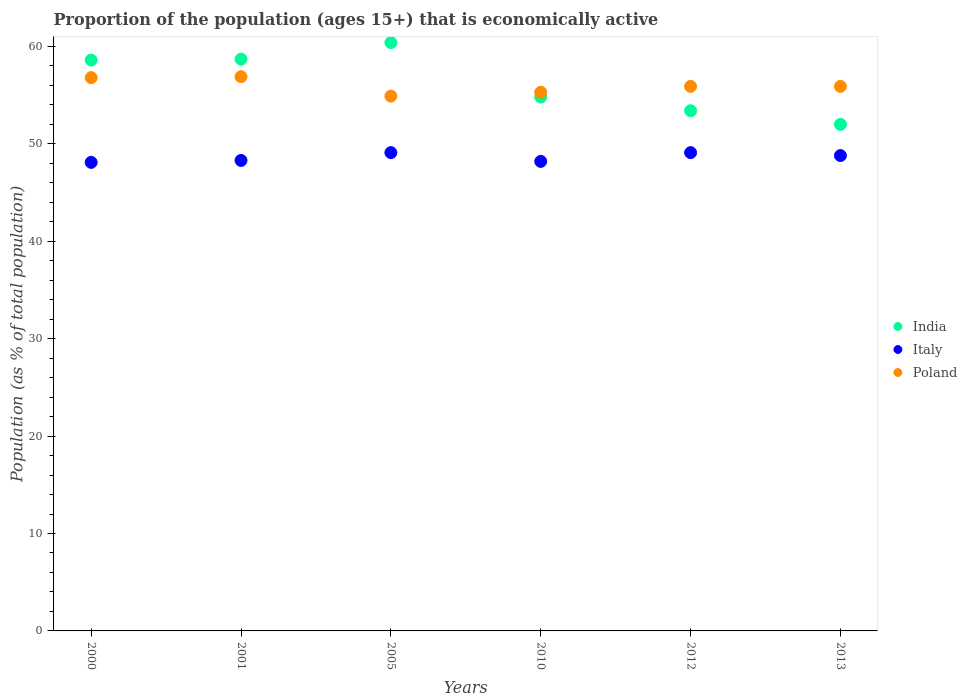What is the proportion of the population that is economically active in Poland in 2012?
Give a very brief answer. 55.9. Across all years, what is the maximum proportion of the population that is economically active in Poland?
Keep it short and to the point. 56.9. Across all years, what is the minimum proportion of the population that is economically active in India?
Keep it short and to the point. 52. In which year was the proportion of the population that is economically active in Poland maximum?
Provide a succinct answer. 2001. In which year was the proportion of the population that is economically active in Poland minimum?
Your answer should be compact. 2005. What is the total proportion of the population that is economically active in Poland in the graph?
Ensure brevity in your answer.  335.7. What is the difference between the proportion of the population that is economically active in Italy in 2005 and that in 2010?
Keep it short and to the point. 0.9. What is the difference between the proportion of the population that is economically active in India in 2001 and the proportion of the population that is economically active in Poland in 2005?
Keep it short and to the point. 3.8. What is the average proportion of the population that is economically active in Poland per year?
Ensure brevity in your answer.  55.95. In the year 2012, what is the difference between the proportion of the population that is economically active in Poland and proportion of the population that is economically active in Italy?
Offer a very short reply. 6.8. What is the ratio of the proportion of the population that is economically active in Italy in 2001 to that in 2012?
Offer a very short reply. 0.98. What is the difference between the highest and the second highest proportion of the population that is economically active in Italy?
Offer a very short reply. 0. Is the sum of the proportion of the population that is economically active in Italy in 2005 and 2012 greater than the maximum proportion of the population that is economically active in India across all years?
Your answer should be very brief. Yes. Is it the case that in every year, the sum of the proportion of the population that is economically active in India and proportion of the population that is economically active in Italy  is greater than the proportion of the population that is economically active in Poland?
Your response must be concise. Yes. How many dotlines are there?
Provide a short and direct response. 3. What is the difference between two consecutive major ticks on the Y-axis?
Your answer should be compact. 10. Does the graph contain any zero values?
Provide a succinct answer. No. Does the graph contain grids?
Keep it short and to the point. No. What is the title of the graph?
Offer a very short reply. Proportion of the population (ages 15+) that is economically active. Does "Maldives" appear as one of the legend labels in the graph?
Your response must be concise. No. What is the label or title of the X-axis?
Offer a very short reply. Years. What is the label or title of the Y-axis?
Your response must be concise. Population (as % of total population). What is the Population (as % of total population) in India in 2000?
Provide a succinct answer. 58.6. What is the Population (as % of total population) in Italy in 2000?
Your answer should be very brief. 48.1. What is the Population (as % of total population) in Poland in 2000?
Offer a very short reply. 56.8. What is the Population (as % of total population) of India in 2001?
Your response must be concise. 58.7. What is the Population (as % of total population) in Italy in 2001?
Give a very brief answer. 48.3. What is the Population (as % of total population) in Poland in 2001?
Ensure brevity in your answer.  56.9. What is the Population (as % of total population) in India in 2005?
Make the answer very short. 60.4. What is the Population (as % of total population) in Italy in 2005?
Provide a short and direct response. 49.1. What is the Population (as % of total population) of Poland in 2005?
Your answer should be very brief. 54.9. What is the Population (as % of total population) in India in 2010?
Offer a very short reply. 54.8. What is the Population (as % of total population) of Italy in 2010?
Offer a very short reply. 48.2. What is the Population (as % of total population) of Poland in 2010?
Your answer should be very brief. 55.3. What is the Population (as % of total population) in India in 2012?
Offer a very short reply. 53.4. What is the Population (as % of total population) in Italy in 2012?
Your response must be concise. 49.1. What is the Population (as % of total population) of Poland in 2012?
Provide a short and direct response. 55.9. What is the Population (as % of total population) in Italy in 2013?
Make the answer very short. 48.8. What is the Population (as % of total population) in Poland in 2013?
Your answer should be compact. 55.9. Across all years, what is the maximum Population (as % of total population) of India?
Your answer should be compact. 60.4. Across all years, what is the maximum Population (as % of total population) of Italy?
Your response must be concise. 49.1. Across all years, what is the maximum Population (as % of total population) of Poland?
Offer a very short reply. 56.9. Across all years, what is the minimum Population (as % of total population) of India?
Offer a terse response. 52. Across all years, what is the minimum Population (as % of total population) in Italy?
Offer a terse response. 48.1. Across all years, what is the minimum Population (as % of total population) of Poland?
Your answer should be compact. 54.9. What is the total Population (as % of total population) in India in the graph?
Offer a terse response. 337.9. What is the total Population (as % of total population) of Italy in the graph?
Provide a succinct answer. 291.6. What is the total Population (as % of total population) of Poland in the graph?
Provide a short and direct response. 335.7. What is the difference between the Population (as % of total population) in Italy in 2000 and that in 2005?
Keep it short and to the point. -1. What is the difference between the Population (as % of total population) in Poland in 2000 and that in 2005?
Give a very brief answer. 1.9. What is the difference between the Population (as % of total population) of Italy in 2000 and that in 2010?
Your response must be concise. -0.1. What is the difference between the Population (as % of total population) of Poland in 2000 and that in 2012?
Your answer should be compact. 0.9. What is the difference between the Population (as % of total population) of India in 2001 and that in 2005?
Your response must be concise. -1.7. What is the difference between the Population (as % of total population) of India in 2001 and that in 2010?
Your answer should be very brief. 3.9. What is the difference between the Population (as % of total population) in Italy in 2001 and that in 2010?
Give a very brief answer. 0.1. What is the difference between the Population (as % of total population) of Poland in 2001 and that in 2010?
Your answer should be very brief. 1.6. What is the difference between the Population (as % of total population) in India in 2001 and that in 2012?
Give a very brief answer. 5.3. What is the difference between the Population (as % of total population) in Italy in 2001 and that in 2013?
Keep it short and to the point. -0.5. What is the difference between the Population (as % of total population) in Poland in 2001 and that in 2013?
Provide a short and direct response. 1. What is the difference between the Population (as % of total population) in India in 2005 and that in 2010?
Your response must be concise. 5.6. What is the difference between the Population (as % of total population) in Italy in 2005 and that in 2010?
Provide a succinct answer. 0.9. What is the difference between the Population (as % of total population) of India in 2005 and that in 2012?
Provide a short and direct response. 7. What is the difference between the Population (as % of total population) in India in 2010 and that in 2012?
Provide a succinct answer. 1.4. What is the difference between the Population (as % of total population) of Italy in 2010 and that in 2012?
Offer a very short reply. -0.9. What is the difference between the Population (as % of total population) of Poland in 2010 and that in 2012?
Offer a very short reply. -0.6. What is the difference between the Population (as % of total population) in Italy in 2010 and that in 2013?
Make the answer very short. -0.6. What is the difference between the Population (as % of total population) of Italy in 2012 and that in 2013?
Provide a succinct answer. 0.3. What is the difference between the Population (as % of total population) of India in 2000 and the Population (as % of total population) of Poland in 2001?
Make the answer very short. 1.7. What is the difference between the Population (as % of total population) of Italy in 2000 and the Population (as % of total population) of Poland in 2001?
Your answer should be compact. -8.8. What is the difference between the Population (as % of total population) in India in 2000 and the Population (as % of total population) in Italy in 2005?
Offer a terse response. 9.5. What is the difference between the Population (as % of total population) of India in 2000 and the Population (as % of total population) of Italy in 2010?
Offer a terse response. 10.4. What is the difference between the Population (as % of total population) of Italy in 2000 and the Population (as % of total population) of Poland in 2010?
Your response must be concise. -7.2. What is the difference between the Population (as % of total population) in India in 2000 and the Population (as % of total population) in Italy in 2013?
Provide a succinct answer. 9.8. What is the difference between the Population (as % of total population) of India in 2000 and the Population (as % of total population) of Poland in 2013?
Offer a very short reply. 2.7. What is the difference between the Population (as % of total population) of India in 2001 and the Population (as % of total population) of Poland in 2005?
Your response must be concise. 3.8. What is the difference between the Population (as % of total population) of Italy in 2001 and the Population (as % of total population) of Poland in 2005?
Provide a short and direct response. -6.6. What is the difference between the Population (as % of total population) in India in 2001 and the Population (as % of total population) in Italy in 2010?
Give a very brief answer. 10.5. What is the difference between the Population (as % of total population) in India in 2001 and the Population (as % of total population) in Poland in 2010?
Offer a very short reply. 3.4. What is the difference between the Population (as % of total population) of India in 2001 and the Population (as % of total population) of Italy in 2012?
Keep it short and to the point. 9.6. What is the difference between the Population (as % of total population) in India in 2001 and the Population (as % of total population) in Poland in 2013?
Your answer should be compact. 2.8. What is the difference between the Population (as % of total population) in India in 2005 and the Population (as % of total population) in Poland in 2010?
Make the answer very short. 5.1. What is the difference between the Population (as % of total population) of India in 2005 and the Population (as % of total population) of Italy in 2012?
Offer a terse response. 11.3. What is the difference between the Population (as % of total population) of India in 2005 and the Population (as % of total population) of Poland in 2012?
Provide a short and direct response. 4.5. What is the difference between the Population (as % of total population) of India in 2005 and the Population (as % of total population) of Italy in 2013?
Give a very brief answer. 11.6. What is the difference between the Population (as % of total population) of Italy in 2005 and the Population (as % of total population) of Poland in 2013?
Give a very brief answer. -6.8. What is the difference between the Population (as % of total population) of India in 2010 and the Population (as % of total population) of Italy in 2012?
Your response must be concise. 5.7. What is the difference between the Population (as % of total population) of Italy in 2010 and the Population (as % of total population) of Poland in 2012?
Your response must be concise. -7.7. What is the difference between the Population (as % of total population) in India in 2010 and the Population (as % of total population) in Italy in 2013?
Your answer should be compact. 6. What is the difference between the Population (as % of total population) in Italy in 2010 and the Population (as % of total population) in Poland in 2013?
Provide a short and direct response. -7.7. What is the average Population (as % of total population) in India per year?
Provide a succinct answer. 56.32. What is the average Population (as % of total population) in Italy per year?
Provide a succinct answer. 48.6. What is the average Population (as % of total population) in Poland per year?
Make the answer very short. 55.95. In the year 2000, what is the difference between the Population (as % of total population) of India and Population (as % of total population) of Italy?
Make the answer very short. 10.5. In the year 2001, what is the difference between the Population (as % of total population) of India and Population (as % of total population) of Poland?
Give a very brief answer. 1.8. In the year 2005, what is the difference between the Population (as % of total population) in India and Population (as % of total population) in Italy?
Ensure brevity in your answer.  11.3. In the year 2005, what is the difference between the Population (as % of total population) in Italy and Population (as % of total population) in Poland?
Provide a succinct answer. -5.8. In the year 2012, what is the difference between the Population (as % of total population) of Italy and Population (as % of total population) of Poland?
Offer a terse response. -6.8. In the year 2013, what is the difference between the Population (as % of total population) in India and Population (as % of total population) in Italy?
Your answer should be compact. 3.2. In the year 2013, what is the difference between the Population (as % of total population) in India and Population (as % of total population) in Poland?
Your answer should be very brief. -3.9. In the year 2013, what is the difference between the Population (as % of total population) of Italy and Population (as % of total population) of Poland?
Provide a succinct answer. -7.1. What is the ratio of the Population (as % of total population) in Poland in 2000 to that in 2001?
Make the answer very short. 1. What is the ratio of the Population (as % of total population) in India in 2000 to that in 2005?
Keep it short and to the point. 0.97. What is the ratio of the Population (as % of total population) of Italy in 2000 to that in 2005?
Make the answer very short. 0.98. What is the ratio of the Population (as % of total population) of Poland in 2000 to that in 2005?
Your response must be concise. 1.03. What is the ratio of the Population (as % of total population) of India in 2000 to that in 2010?
Offer a terse response. 1.07. What is the ratio of the Population (as % of total population) of Poland in 2000 to that in 2010?
Provide a short and direct response. 1.03. What is the ratio of the Population (as % of total population) of India in 2000 to that in 2012?
Provide a short and direct response. 1.1. What is the ratio of the Population (as % of total population) in Italy in 2000 to that in 2012?
Your answer should be very brief. 0.98. What is the ratio of the Population (as % of total population) of Poland in 2000 to that in 2012?
Provide a short and direct response. 1.02. What is the ratio of the Population (as % of total population) in India in 2000 to that in 2013?
Offer a very short reply. 1.13. What is the ratio of the Population (as % of total population) in Italy in 2000 to that in 2013?
Your answer should be very brief. 0.99. What is the ratio of the Population (as % of total population) in Poland in 2000 to that in 2013?
Provide a succinct answer. 1.02. What is the ratio of the Population (as % of total population) in India in 2001 to that in 2005?
Offer a terse response. 0.97. What is the ratio of the Population (as % of total population) of Italy in 2001 to that in 2005?
Make the answer very short. 0.98. What is the ratio of the Population (as % of total population) of Poland in 2001 to that in 2005?
Give a very brief answer. 1.04. What is the ratio of the Population (as % of total population) in India in 2001 to that in 2010?
Keep it short and to the point. 1.07. What is the ratio of the Population (as % of total population) in Italy in 2001 to that in 2010?
Provide a succinct answer. 1. What is the ratio of the Population (as % of total population) of Poland in 2001 to that in 2010?
Give a very brief answer. 1.03. What is the ratio of the Population (as % of total population) of India in 2001 to that in 2012?
Your response must be concise. 1.1. What is the ratio of the Population (as % of total population) of Italy in 2001 to that in 2012?
Offer a terse response. 0.98. What is the ratio of the Population (as % of total population) of Poland in 2001 to that in 2012?
Make the answer very short. 1.02. What is the ratio of the Population (as % of total population) in India in 2001 to that in 2013?
Provide a succinct answer. 1.13. What is the ratio of the Population (as % of total population) in Poland in 2001 to that in 2013?
Make the answer very short. 1.02. What is the ratio of the Population (as % of total population) of India in 2005 to that in 2010?
Offer a very short reply. 1.1. What is the ratio of the Population (as % of total population) in Italy in 2005 to that in 2010?
Give a very brief answer. 1.02. What is the ratio of the Population (as % of total population) in Poland in 2005 to that in 2010?
Your response must be concise. 0.99. What is the ratio of the Population (as % of total population) of India in 2005 to that in 2012?
Your response must be concise. 1.13. What is the ratio of the Population (as % of total population) in Poland in 2005 to that in 2012?
Provide a succinct answer. 0.98. What is the ratio of the Population (as % of total population) of India in 2005 to that in 2013?
Offer a very short reply. 1.16. What is the ratio of the Population (as % of total population) in Italy in 2005 to that in 2013?
Provide a short and direct response. 1.01. What is the ratio of the Population (as % of total population) in Poland in 2005 to that in 2013?
Make the answer very short. 0.98. What is the ratio of the Population (as % of total population) in India in 2010 to that in 2012?
Your response must be concise. 1.03. What is the ratio of the Population (as % of total population) in Italy in 2010 to that in 2012?
Ensure brevity in your answer.  0.98. What is the ratio of the Population (as % of total population) of Poland in 2010 to that in 2012?
Your answer should be compact. 0.99. What is the ratio of the Population (as % of total population) in India in 2010 to that in 2013?
Provide a short and direct response. 1.05. What is the ratio of the Population (as % of total population) of Italy in 2010 to that in 2013?
Keep it short and to the point. 0.99. What is the ratio of the Population (as % of total population) of Poland in 2010 to that in 2013?
Your answer should be compact. 0.99. What is the ratio of the Population (as % of total population) in India in 2012 to that in 2013?
Make the answer very short. 1.03. What is the ratio of the Population (as % of total population) in Poland in 2012 to that in 2013?
Offer a very short reply. 1. What is the difference between the highest and the second highest Population (as % of total population) in India?
Provide a short and direct response. 1.7. What is the difference between the highest and the second highest Population (as % of total population) in Italy?
Provide a succinct answer. 0. What is the difference between the highest and the lowest Population (as % of total population) of India?
Offer a very short reply. 8.4. What is the difference between the highest and the lowest Population (as % of total population) of Italy?
Your answer should be compact. 1. 